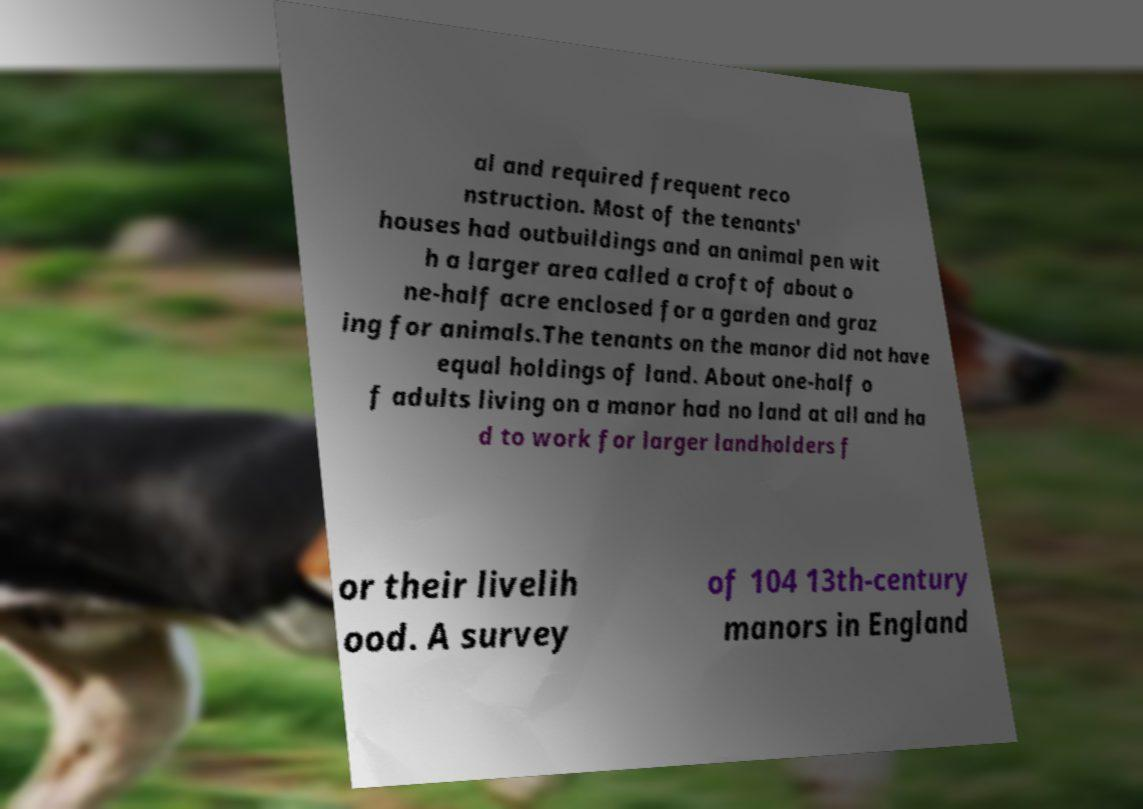I need the written content from this picture converted into text. Can you do that? al and required frequent reco nstruction. Most of the tenants' houses had outbuildings and an animal pen wit h a larger area called a croft of about o ne-half acre enclosed for a garden and graz ing for animals.The tenants on the manor did not have equal holdings of land. About one-half o f adults living on a manor had no land at all and ha d to work for larger landholders f or their livelih ood. A survey of 104 13th-century manors in England 